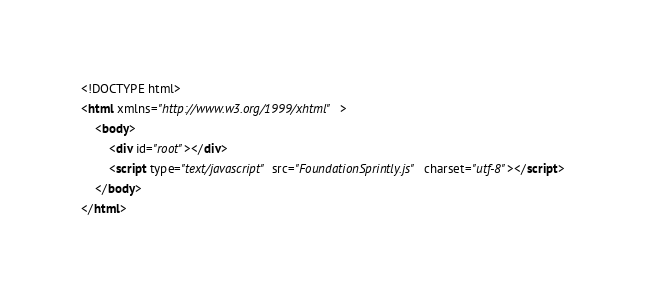Convert code to text. <code><loc_0><loc_0><loc_500><loc_500><_HTML_><!DOCTYPE html>
<html xmlns="http://www.w3.org/1999/xhtml">
    <body>
        <div id="root"></div>
        <script type="text/javascript" src="FoundationSprintly.js" charset="utf-8"></script>
    </body>
</html></code> 